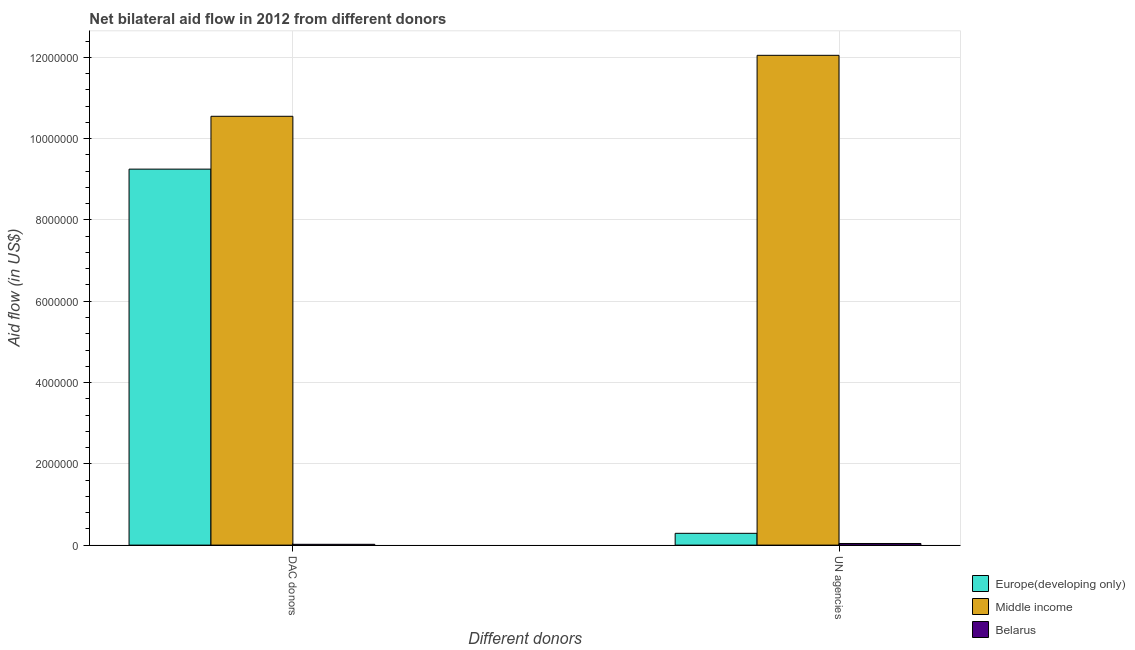How many groups of bars are there?
Ensure brevity in your answer.  2. Are the number of bars per tick equal to the number of legend labels?
Provide a short and direct response. Yes. How many bars are there on the 1st tick from the left?
Keep it short and to the point. 3. What is the label of the 2nd group of bars from the left?
Make the answer very short. UN agencies. What is the aid flow from dac donors in Europe(developing only)?
Your answer should be very brief. 9.25e+06. Across all countries, what is the maximum aid flow from dac donors?
Your answer should be very brief. 1.06e+07. Across all countries, what is the minimum aid flow from dac donors?
Your response must be concise. 2.00e+04. In which country was the aid flow from dac donors minimum?
Ensure brevity in your answer.  Belarus. What is the total aid flow from un agencies in the graph?
Provide a succinct answer. 1.24e+07. What is the difference between the aid flow from dac donors in Europe(developing only) and that in Middle income?
Your response must be concise. -1.30e+06. What is the difference between the aid flow from dac donors in Middle income and the aid flow from un agencies in Europe(developing only)?
Your answer should be compact. 1.03e+07. What is the average aid flow from un agencies per country?
Give a very brief answer. 4.13e+06. What is the difference between the aid flow from dac donors and aid flow from un agencies in Belarus?
Provide a short and direct response. -2.00e+04. In how many countries, is the aid flow from un agencies greater than 7200000 US$?
Keep it short and to the point. 1. What is the ratio of the aid flow from dac donors in Middle income to that in Belarus?
Your answer should be very brief. 527.5. Is the aid flow from dac donors in Europe(developing only) less than that in Middle income?
Offer a terse response. Yes. In how many countries, is the aid flow from un agencies greater than the average aid flow from un agencies taken over all countries?
Make the answer very short. 1. What does the 3rd bar from the left in UN agencies represents?
Your response must be concise. Belarus. What does the 3rd bar from the right in DAC donors represents?
Your answer should be very brief. Europe(developing only). How many bars are there?
Your answer should be compact. 6. Are all the bars in the graph horizontal?
Your answer should be very brief. No. How many countries are there in the graph?
Make the answer very short. 3. Are the values on the major ticks of Y-axis written in scientific E-notation?
Give a very brief answer. No. Does the graph contain any zero values?
Keep it short and to the point. No. How many legend labels are there?
Provide a succinct answer. 3. How are the legend labels stacked?
Provide a short and direct response. Vertical. What is the title of the graph?
Provide a succinct answer. Net bilateral aid flow in 2012 from different donors. Does "European Union" appear as one of the legend labels in the graph?
Offer a terse response. No. What is the label or title of the X-axis?
Offer a very short reply. Different donors. What is the label or title of the Y-axis?
Your answer should be compact. Aid flow (in US$). What is the Aid flow (in US$) of Europe(developing only) in DAC donors?
Provide a short and direct response. 9.25e+06. What is the Aid flow (in US$) in Middle income in DAC donors?
Your answer should be compact. 1.06e+07. What is the Aid flow (in US$) of Belarus in DAC donors?
Give a very brief answer. 2.00e+04. What is the Aid flow (in US$) of Europe(developing only) in UN agencies?
Ensure brevity in your answer.  2.90e+05. What is the Aid flow (in US$) in Middle income in UN agencies?
Provide a short and direct response. 1.20e+07. What is the Aid flow (in US$) in Belarus in UN agencies?
Make the answer very short. 4.00e+04. Across all Different donors, what is the maximum Aid flow (in US$) in Europe(developing only)?
Make the answer very short. 9.25e+06. Across all Different donors, what is the maximum Aid flow (in US$) of Middle income?
Your response must be concise. 1.20e+07. Across all Different donors, what is the minimum Aid flow (in US$) of Middle income?
Offer a terse response. 1.06e+07. What is the total Aid flow (in US$) in Europe(developing only) in the graph?
Offer a terse response. 9.54e+06. What is the total Aid flow (in US$) in Middle income in the graph?
Offer a terse response. 2.26e+07. What is the difference between the Aid flow (in US$) of Europe(developing only) in DAC donors and that in UN agencies?
Your answer should be very brief. 8.96e+06. What is the difference between the Aid flow (in US$) of Middle income in DAC donors and that in UN agencies?
Ensure brevity in your answer.  -1.50e+06. What is the difference between the Aid flow (in US$) of Belarus in DAC donors and that in UN agencies?
Provide a succinct answer. -2.00e+04. What is the difference between the Aid flow (in US$) in Europe(developing only) in DAC donors and the Aid flow (in US$) in Middle income in UN agencies?
Your answer should be very brief. -2.80e+06. What is the difference between the Aid flow (in US$) in Europe(developing only) in DAC donors and the Aid flow (in US$) in Belarus in UN agencies?
Your answer should be compact. 9.21e+06. What is the difference between the Aid flow (in US$) of Middle income in DAC donors and the Aid flow (in US$) of Belarus in UN agencies?
Your answer should be compact. 1.05e+07. What is the average Aid flow (in US$) of Europe(developing only) per Different donors?
Provide a succinct answer. 4.77e+06. What is the average Aid flow (in US$) in Middle income per Different donors?
Provide a short and direct response. 1.13e+07. What is the average Aid flow (in US$) of Belarus per Different donors?
Your answer should be compact. 3.00e+04. What is the difference between the Aid flow (in US$) in Europe(developing only) and Aid flow (in US$) in Middle income in DAC donors?
Provide a short and direct response. -1.30e+06. What is the difference between the Aid flow (in US$) in Europe(developing only) and Aid flow (in US$) in Belarus in DAC donors?
Offer a terse response. 9.23e+06. What is the difference between the Aid flow (in US$) of Middle income and Aid flow (in US$) of Belarus in DAC donors?
Give a very brief answer. 1.05e+07. What is the difference between the Aid flow (in US$) of Europe(developing only) and Aid flow (in US$) of Middle income in UN agencies?
Your answer should be very brief. -1.18e+07. What is the difference between the Aid flow (in US$) in Middle income and Aid flow (in US$) in Belarus in UN agencies?
Offer a terse response. 1.20e+07. What is the ratio of the Aid flow (in US$) in Europe(developing only) in DAC donors to that in UN agencies?
Make the answer very short. 31.9. What is the ratio of the Aid flow (in US$) in Middle income in DAC donors to that in UN agencies?
Your response must be concise. 0.88. What is the ratio of the Aid flow (in US$) in Belarus in DAC donors to that in UN agencies?
Make the answer very short. 0.5. What is the difference between the highest and the second highest Aid flow (in US$) in Europe(developing only)?
Your answer should be very brief. 8.96e+06. What is the difference between the highest and the second highest Aid flow (in US$) in Middle income?
Your response must be concise. 1.50e+06. What is the difference between the highest and the second highest Aid flow (in US$) in Belarus?
Offer a very short reply. 2.00e+04. What is the difference between the highest and the lowest Aid flow (in US$) in Europe(developing only)?
Offer a very short reply. 8.96e+06. What is the difference between the highest and the lowest Aid flow (in US$) in Middle income?
Offer a terse response. 1.50e+06. What is the difference between the highest and the lowest Aid flow (in US$) in Belarus?
Offer a very short reply. 2.00e+04. 